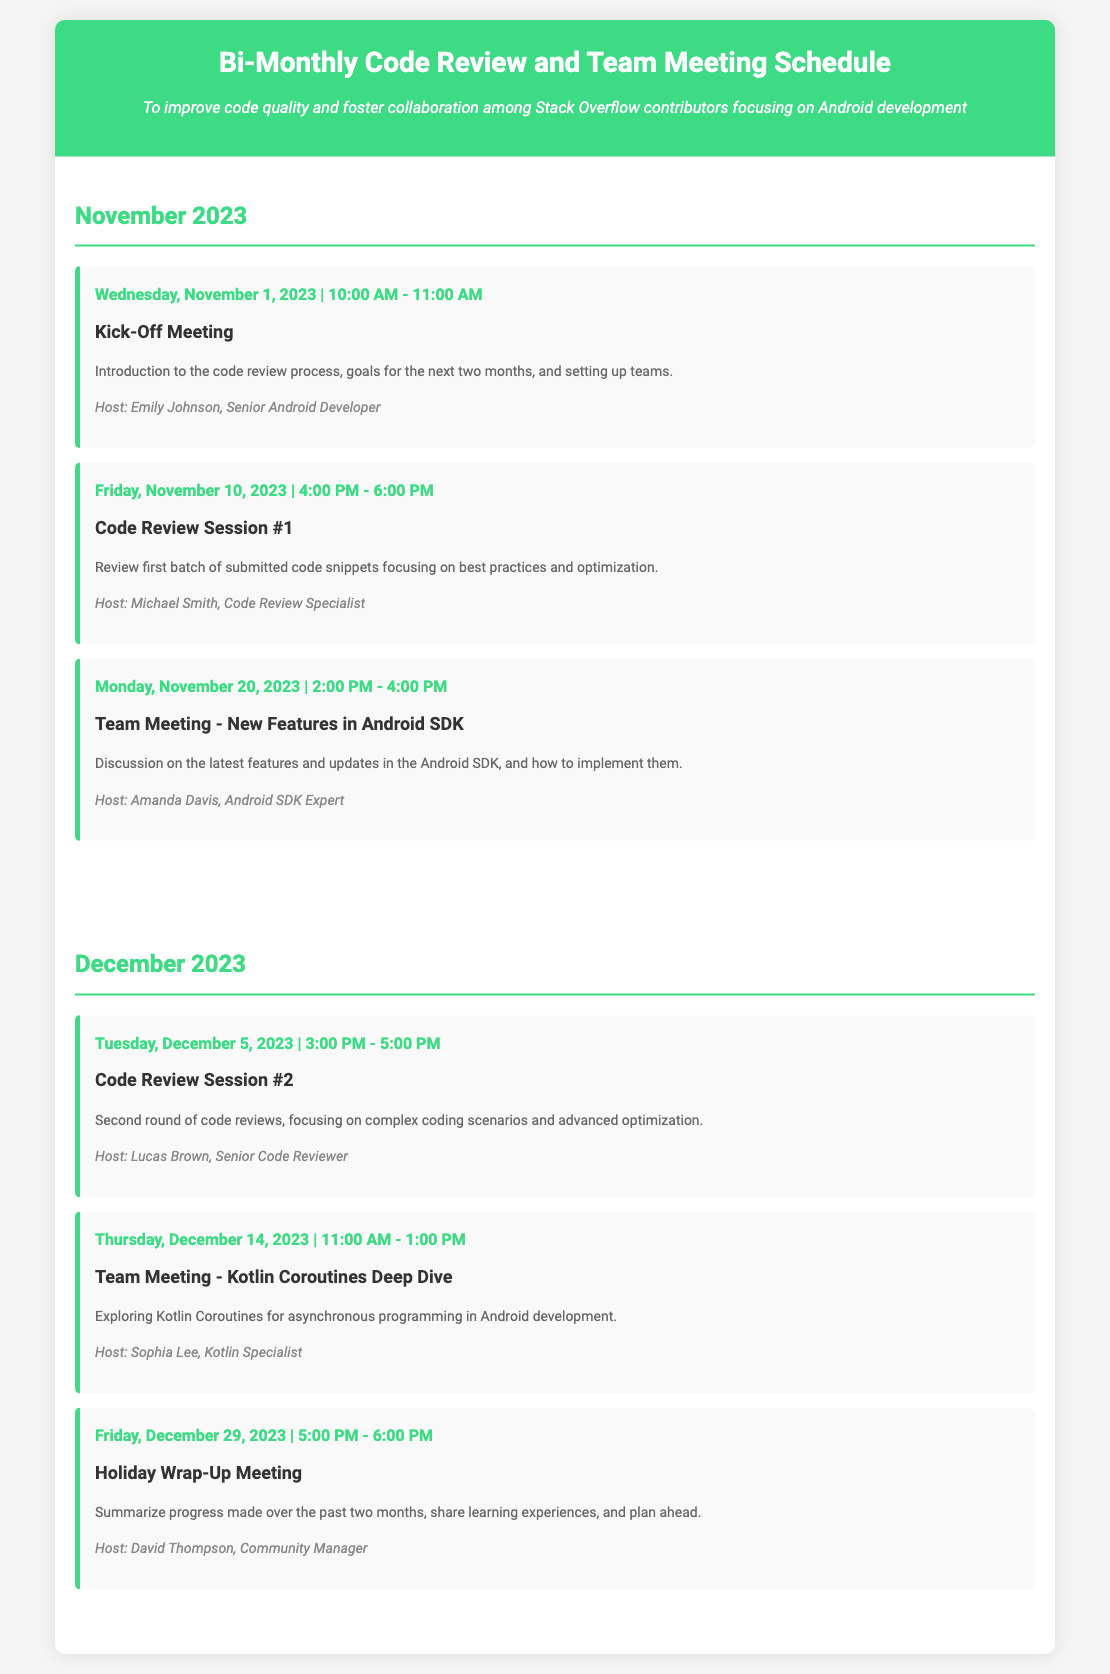Who is hosting the Team Meeting on New Features in Android SDK? The host for the Team Meeting on New Features in Android SDK is Amanda Davis.
Answer: Amanda Davis What is the main focus of Code Review Session #2? The focus of Code Review Session #2 is on complex coding scenarios and advanced optimization.
Answer: Complex coding scenarios and advanced optimization How many events are scheduled in December 2023? There are three events scheduled in December 2023 within the document.
Answer: Three What time does the Holiday Wrap-Up Meeting start? The Holiday Wrap-Up Meeting starts at 5:00 PM on December 29, 2023.
Answer: 5:00 PM Which month has three events listed? The month of December 2023 has three events listed in the document.
Answer: December What is the primary purpose of this meeting schedule? The primary purpose is to improve code quality and foster collaboration among contributors.
Answer: To improve code quality and foster collaboration Who is the host of the Code Review Session #1? The host of Code Review Session #1 is Michael Smith.
Answer: Michael Smith 